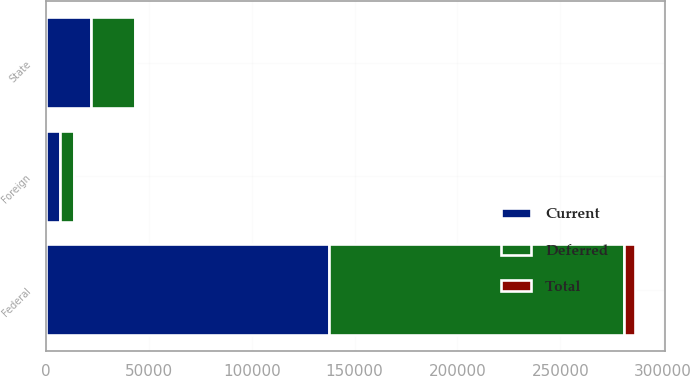<chart> <loc_0><loc_0><loc_500><loc_500><stacked_bar_chart><ecel><fcel>Federal<fcel>State<fcel>Foreign<nl><fcel>Current<fcel>137751<fcel>21780<fcel>6769<nl><fcel>Total<fcel>5501<fcel>243<fcel>96<nl><fcel>Deferred<fcel>143252<fcel>21537<fcel>6673<nl></chart> 